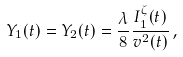Convert formula to latex. <formula><loc_0><loc_0><loc_500><loc_500>Y _ { 1 } ( t ) = Y _ { 2 } ( t ) = \frac { \lambda } { 8 } \frac { I _ { 1 } ^ { \zeta } ( t ) } { v ^ { 2 } ( t ) } \, ,</formula> 